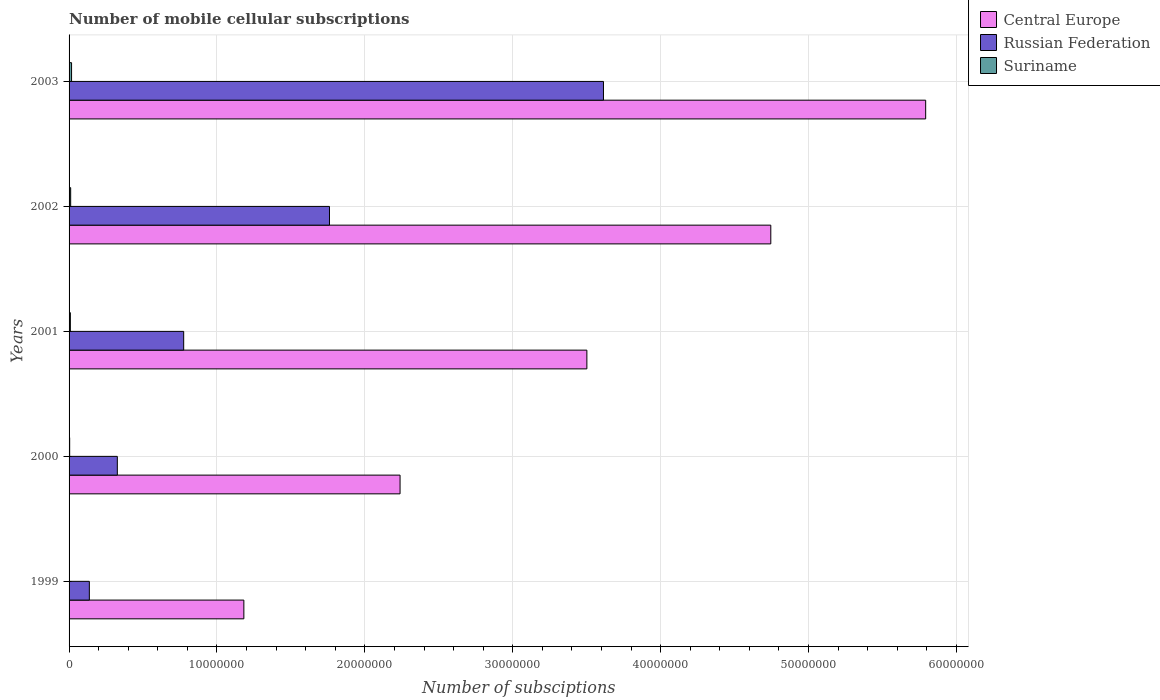How many groups of bars are there?
Your answer should be compact. 5. Are the number of bars per tick equal to the number of legend labels?
Provide a short and direct response. Yes. What is the label of the 4th group of bars from the top?
Provide a short and direct response. 2000. What is the number of mobile cellular subscriptions in Central Europe in 2002?
Provide a short and direct response. 4.74e+07. Across all years, what is the maximum number of mobile cellular subscriptions in Russian Federation?
Your answer should be very brief. 3.61e+07. Across all years, what is the minimum number of mobile cellular subscriptions in Russian Federation?
Make the answer very short. 1.37e+06. In which year was the number of mobile cellular subscriptions in Suriname maximum?
Ensure brevity in your answer.  2003. What is the total number of mobile cellular subscriptions in Russian Federation in the graph?
Provide a succinct answer. 6.61e+07. What is the difference between the number of mobile cellular subscriptions in Suriname in 2000 and that in 2001?
Give a very brief answer. -4.60e+04. What is the difference between the number of mobile cellular subscriptions in Suriname in 1999 and the number of mobile cellular subscriptions in Russian Federation in 2002?
Provide a succinct answer. -1.76e+07. What is the average number of mobile cellular subscriptions in Central Europe per year?
Offer a terse response. 3.49e+07. In the year 2001, what is the difference between the number of mobile cellular subscriptions in Suriname and number of mobile cellular subscriptions in Central Europe?
Provide a succinct answer. -3.49e+07. In how many years, is the number of mobile cellular subscriptions in Central Europe greater than 50000000 ?
Keep it short and to the point. 1. What is the ratio of the number of mobile cellular subscriptions in Suriname in 2000 to that in 2001?
Offer a very short reply. 0.47. Is the difference between the number of mobile cellular subscriptions in Suriname in 2001 and 2002 greater than the difference between the number of mobile cellular subscriptions in Central Europe in 2001 and 2002?
Your response must be concise. Yes. What is the difference between the highest and the second highest number of mobile cellular subscriptions in Suriname?
Provide a short and direct response. 6.02e+04. What is the difference between the highest and the lowest number of mobile cellular subscriptions in Central Europe?
Offer a very short reply. 4.61e+07. In how many years, is the number of mobile cellular subscriptions in Russian Federation greater than the average number of mobile cellular subscriptions in Russian Federation taken over all years?
Provide a succinct answer. 2. What does the 1st bar from the top in 1999 represents?
Give a very brief answer. Suriname. What does the 1st bar from the bottom in 2000 represents?
Offer a terse response. Central Europe. Is it the case that in every year, the sum of the number of mobile cellular subscriptions in Suriname and number of mobile cellular subscriptions in Central Europe is greater than the number of mobile cellular subscriptions in Russian Federation?
Make the answer very short. Yes. How many bars are there?
Provide a succinct answer. 15. What is the difference between two consecutive major ticks on the X-axis?
Provide a short and direct response. 1.00e+07. Does the graph contain grids?
Give a very brief answer. Yes. Where does the legend appear in the graph?
Offer a very short reply. Top right. How many legend labels are there?
Give a very brief answer. 3. How are the legend labels stacked?
Provide a short and direct response. Vertical. What is the title of the graph?
Offer a terse response. Number of mobile cellular subscriptions. Does "Papua New Guinea" appear as one of the legend labels in the graph?
Provide a succinct answer. No. What is the label or title of the X-axis?
Ensure brevity in your answer.  Number of subsciptions. What is the Number of subsciptions in Central Europe in 1999?
Keep it short and to the point. 1.18e+07. What is the Number of subsciptions in Russian Federation in 1999?
Provide a short and direct response. 1.37e+06. What is the Number of subsciptions of Suriname in 1999?
Provide a succinct answer. 1.75e+04. What is the Number of subsciptions in Central Europe in 2000?
Offer a very short reply. 2.24e+07. What is the Number of subsciptions of Russian Federation in 2000?
Your answer should be very brief. 3.26e+06. What is the Number of subsciptions in Suriname in 2000?
Provide a short and direct response. 4.10e+04. What is the Number of subsciptions in Central Europe in 2001?
Provide a short and direct response. 3.50e+07. What is the Number of subsciptions of Russian Federation in 2001?
Provide a succinct answer. 7.75e+06. What is the Number of subsciptions of Suriname in 2001?
Offer a terse response. 8.70e+04. What is the Number of subsciptions in Central Europe in 2002?
Offer a terse response. 4.74e+07. What is the Number of subsciptions in Russian Federation in 2002?
Make the answer very short. 1.76e+07. What is the Number of subsciptions in Suriname in 2002?
Give a very brief answer. 1.08e+05. What is the Number of subsciptions of Central Europe in 2003?
Offer a very short reply. 5.79e+07. What is the Number of subsciptions of Russian Federation in 2003?
Make the answer very short. 3.61e+07. What is the Number of subsciptions in Suriname in 2003?
Provide a succinct answer. 1.69e+05. Across all years, what is the maximum Number of subsciptions in Central Europe?
Give a very brief answer. 5.79e+07. Across all years, what is the maximum Number of subsciptions in Russian Federation?
Your response must be concise. 3.61e+07. Across all years, what is the maximum Number of subsciptions in Suriname?
Offer a terse response. 1.69e+05. Across all years, what is the minimum Number of subsciptions of Central Europe?
Give a very brief answer. 1.18e+07. Across all years, what is the minimum Number of subsciptions in Russian Federation?
Ensure brevity in your answer.  1.37e+06. Across all years, what is the minimum Number of subsciptions of Suriname?
Provide a short and direct response. 1.75e+04. What is the total Number of subsciptions of Central Europe in the graph?
Keep it short and to the point. 1.75e+08. What is the total Number of subsciptions of Russian Federation in the graph?
Your response must be concise. 6.61e+07. What is the total Number of subsciptions of Suriname in the graph?
Make the answer very short. 4.22e+05. What is the difference between the Number of subsciptions in Central Europe in 1999 and that in 2000?
Offer a very short reply. -1.06e+07. What is the difference between the Number of subsciptions in Russian Federation in 1999 and that in 2000?
Provide a succinct answer. -1.89e+06. What is the difference between the Number of subsciptions in Suriname in 1999 and that in 2000?
Make the answer very short. -2.35e+04. What is the difference between the Number of subsciptions in Central Europe in 1999 and that in 2001?
Your response must be concise. -2.32e+07. What is the difference between the Number of subsciptions of Russian Federation in 1999 and that in 2001?
Provide a short and direct response. -6.38e+06. What is the difference between the Number of subsciptions of Suriname in 1999 and that in 2001?
Your response must be concise. -6.95e+04. What is the difference between the Number of subsciptions in Central Europe in 1999 and that in 2002?
Keep it short and to the point. -3.56e+07. What is the difference between the Number of subsciptions in Russian Federation in 1999 and that in 2002?
Keep it short and to the point. -1.62e+07. What is the difference between the Number of subsciptions of Suriname in 1999 and that in 2002?
Ensure brevity in your answer.  -9.09e+04. What is the difference between the Number of subsciptions in Central Europe in 1999 and that in 2003?
Offer a terse response. -4.61e+07. What is the difference between the Number of subsciptions of Russian Federation in 1999 and that in 2003?
Give a very brief answer. -3.48e+07. What is the difference between the Number of subsciptions in Suriname in 1999 and that in 2003?
Offer a terse response. -1.51e+05. What is the difference between the Number of subsciptions in Central Europe in 2000 and that in 2001?
Offer a very short reply. -1.26e+07. What is the difference between the Number of subsciptions in Russian Federation in 2000 and that in 2001?
Make the answer very short. -4.49e+06. What is the difference between the Number of subsciptions in Suriname in 2000 and that in 2001?
Give a very brief answer. -4.60e+04. What is the difference between the Number of subsciptions in Central Europe in 2000 and that in 2002?
Give a very brief answer. -2.51e+07. What is the difference between the Number of subsciptions in Russian Federation in 2000 and that in 2002?
Give a very brief answer. -1.43e+07. What is the difference between the Number of subsciptions of Suriname in 2000 and that in 2002?
Offer a terse response. -6.73e+04. What is the difference between the Number of subsciptions of Central Europe in 2000 and that in 2003?
Your response must be concise. -3.55e+07. What is the difference between the Number of subsciptions of Russian Federation in 2000 and that in 2003?
Your answer should be very brief. -3.29e+07. What is the difference between the Number of subsciptions of Suriname in 2000 and that in 2003?
Offer a very short reply. -1.27e+05. What is the difference between the Number of subsciptions of Central Europe in 2001 and that in 2002?
Offer a terse response. -1.24e+07. What is the difference between the Number of subsciptions of Russian Federation in 2001 and that in 2002?
Your response must be concise. -9.86e+06. What is the difference between the Number of subsciptions in Suriname in 2001 and that in 2002?
Give a very brief answer. -2.14e+04. What is the difference between the Number of subsciptions of Central Europe in 2001 and that in 2003?
Ensure brevity in your answer.  -2.29e+07. What is the difference between the Number of subsciptions of Russian Federation in 2001 and that in 2003?
Your answer should be compact. -2.84e+07. What is the difference between the Number of subsciptions of Suriname in 2001 and that in 2003?
Your answer should be very brief. -8.15e+04. What is the difference between the Number of subsciptions of Central Europe in 2002 and that in 2003?
Keep it short and to the point. -1.05e+07. What is the difference between the Number of subsciptions of Russian Federation in 2002 and that in 2003?
Your answer should be compact. -1.85e+07. What is the difference between the Number of subsciptions in Suriname in 2002 and that in 2003?
Keep it short and to the point. -6.02e+04. What is the difference between the Number of subsciptions in Central Europe in 1999 and the Number of subsciptions in Russian Federation in 2000?
Keep it short and to the point. 8.56e+06. What is the difference between the Number of subsciptions in Central Europe in 1999 and the Number of subsciptions in Suriname in 2000?
Offer a very short reply. 1.18e+07. What is the difference between the Number of subsciptions of Russian Federation in 1999 and the Number of subsciptions of Suriname in 2000?
Give a very brief answer. 1.33e+06. What is the difference between the Number of subsciptions in Central Europe in 1999 and the Number of subsciptions in Russian Federation in 2001?
Keep it short and to the point. 4.07e+06. What is the difference between the Number of subsciptions of Central Europe in 1999 and the Number of subsciptions of Suriname in 2001?
Your answer should be very brief. 1.17e+07. What is the difference between the Number of subsciptions of Russian Federation in 1999 and the Number of subsciptions of Suriname in 2001?
Provide a succinct answer. 1.28e+06. What is the difference between the Number of subsciptions of Central Europe in 1999 and the Number of subsciptions of Russian Federation in 2002?
Offer a very short reply. -5.79e+06. What is the difference between the Number of subsciptions in Central Europe in 1999 and the Number of subsciptions in Suriname in 2002?
Ensure brevity in your answer.  1.17e+07. What is the difference between the Number of subsciptions in Russian Federation in 1999 and the Number of subsciptions in Suriname in 2002?
Ensure brevity in your answer.  1.26e+06. What is the difference between the Number of subsciptions of Central Europe in 1999 and the Number of subsciptions of Russian Federation in 2003?
Ensure brevity in your answer.  -2.43e+07. What is the difference between the Number of subsciptions in Central Europe in 1999 and the Number of subsciptions in Suriname in 2003?
Offer a very short reply. 1.17e+07. What is the difference between the Number of subsciptions in Russian Federation in 1999 and the Number of subsciptions in Suriname in 2003?
Your answer should be very brief. 1.20e+06. What is the difference between the Number of subsciptions of Central Europe in 2000 and the Number of subsciptions of Russian Federation in 2001?
Offer a terse response. 1.46e+07. What is the difference between the Number of subsciptions in Central Europe in 2000 and the Number of subsciptions in Suriname in 2001?
Your response must be concise. 2.23e+07. What is the difference between the Number of subsciptions of Russian Federation in 2000 and the Number of subsciptions of Suriname in 2001?
Your answer should be very brief. 3.18e+06. What is the difference between the Number of subsciptions in Central Europe in 2000 and the Number of subsciptions in Russian Federation in 2002?
Provide a short and direct response. 4.77e+06. What is the difference between the Number of subsciptions in Central Europe in 2000 and the Number of subsciptions in Suriname in 2002?
Your response must be concise. 2.23e+07. What is the difference between the Number of subsciptions of Russian Federation in 2000 and the Number of subsciptions of Suriname in 2002?
Your answer should be compact. 3.15e+06. What is the difference between the Number of subsciptions of Central Europe in 2000 and the Number of subsciptions of Russian Federation in 2003?
Your answer should be very brief. -1.38e+07. What is the difference between the Number of subsciptions in Central Europe in 2000 and the Number of subsciptions in Suriname in 2003?
Offer a very short reply. 2.22e+07. What is the difference between the Number of subsciptions in Russian Federation in 2000 and the Number of subsciptions in Suriname in 2003?
Your answer should be very brief. 3.09e+06. What is the difference between the Number of subsciptions of Central Europe in 2001 and the Number of subsciptions of Russian Federation in 2002?
Provide a short and direct response. 1.74e+07. What is the difference between the Number of subsciptions of Central Europe in 2001 and the Number of subsciptions of Suriname in 2002?
Provide a succinct answer. 3.49e+07. What is the difference between the Number of subsciptions in Russian Federation in 2001 and the Number of subsciptions in Suriname in 2002?
Ensure brevity in your answer.  7.64e+06. What is the difference between the Number of subsciptions of Central Europe in 2001 and the Number of subsciptions of Russian Federation in 2003?
Provide a succinct answer. -1.12e+06. What is the difference between the Number of subsciptions of Central Europe in 2001 and the Number of subsciptions of Suriname in 2003?
Make the answer very short. 3.48e+07. What is the difference between the Number of subsciptions in Russian Federation in 2001 and the Number of subsciptions in Suriname in 2003?
Offer a very short reply. 7.58e+06. What is the difference between the Number of subsciptions in Central Europe in 2002 and the Number of subsciptions in Russian Federation in 2003?
Make the answer very short. 1.13e+07. What is the difference between the Number of subsciptions in Central Europe in 2002 and the Number of subsciptions in Suriname in 2003?
Give a very brief answer. 4.73e+07. What is the difference between the Number of subsciptions in Russian Federation in 2002 and the Number of subsciptions in Suriname in 2003?
Your response must be concise. 1.74e+07. What is the average Number of subsciptions in Central Europe per year?
Your answer should be compact. 3.49e+07. What is the average Number of subsciptions in Russian Federation per year?
Offer a very short reply. 1.32e+07. What is the average Number of subsciptions of Suriname per year?
Offer a very short reply. 8.45e+04. In the year 1999, what is the difference between the Number of subsciptions in Central Europe and Number of subsciptions in Russian Federation?
Your response must be concise. 1.04e+07. In the year 1999, what is the difference between the Number of subsciptions of Central Europe and Number of subsciptions of Suriname?
Offer a terse response. 1.18e+07. In the year 1999, what is the difference between the Number of subsciptions of Russian Federation and Number of subsciptions of Suriname?
Provide a short and direct response. 1.35e+06. In the year 2000, what is the difference between the Number of subsciptions of Central Europe and Number of subsciptions of Russian Federation?
Give a very brief answer. 1.91e+07. In the year 2000, what is the difference between the Number of subsciptions in Central Europe and Number of subsciptions in Suriname?
Offer a very short reply. 2.23e+07. In the year 2000, what is the difference between the Number of subsciptions of Russian Federation and Number of subsciptions of Suriname?
Keep it short and to the point. 3.22e+06. In the year 2001, what is the difference between the Number of subsciptions of Central Europe and Number of subsciptions of Russian Federation?
Provide a succinct answer. 2.73e+07. In the year 2001, what is the difference between the Number of subsciptions in Central Europe and Number of subsciptions in Suriname?
Offer a terse response. 3.49e+07. In the year 2001, what is the difference between the Number of subsciptions in Russian Federation and Number of subsciptions in Suriname?
Your answer should be very brief. 7.66e+06. In the year 2002, what is the difference between the Number of subsciptions of Central Europe and Number of subsciptions of Russian Federation?
Your response must be concise. 2.98e+07. In the year 2002, what is the difference between the Number of subsciptions of Central Europe and Number of subsciptions of Suriname?
Ensure brevity in your answer.  4.73e+07. In the year 2002, what is the difference between the Number of subsciptions of Russian Federation and Number of subsciptions of Suriname?
Provide a succinct answer. 1.75e+07. In the year 2003, what is the difference between the Number of subsciptions of Central Europe and Number of subsciptions of Russian Federation?
Offer a terse response. 2.18e+07. In the year 2003, what is the difference between the Number of subsciptions of Central Europe and Number of subsciptions of Suriname?
Offer a terse response. 5.78e+07. In the year 2003, what is the difference between the Number of subsciptions in Russian Federation and Number of subsciptions in Suriname?
Give a very brief answer. 3.60e+07. What is the ratio of the Number of subsciptions in Central Europe in 1999 to that in 2000?
Ensure brevity in your answer.  0.53. What is the ratio of the Number of subsciptions in Russian Federation in 1999 to that in 2000?
Make the answer very short. 0.42. What is the ratio of the Number of subsciptions of Suriname in 1999 to that in 2000?
Your answer should be compact. 0.43. What is the ratio of the Number of subsciptions of Central Europe in 1999 to that in 2001?
Your answer should be very brief. 0.34. What is the ratio of the Number of subsciptions of Russian Federation in 1999 to that in 2001?
Keep it short and to the point. 0.18. What is the ratio of the Number of subsciptions of Suriname in 1999 to that in 2001?
Give a very brief answer. 0.2. What is the ratio of the Number of subsciptions of Central Europe in 1999 to that in 2002?
Provide a succinct answer. 0.25. What is the ratio of the Number of subsciptions of Russian Federation in 1999 to that in 2002?
Keep it short and to the point. 0.08. What is the ratio of the Number of subsciptions in Suriname in 1999 to that in 2002?
Provide a short and direct response. 0.16. What is the ratio of the Number of subsciptions of Central Europe in 1999 to that in 2003?
Your answer should be very brief. 0.2. What is the ratio of the Number of subsciptions of Russian Federation in 1999 to that in 2003?
Keep it short and to the point. 0.04. What is the ratio of the Number of subsciptions in Suriname in 1999 to that in 2003?
Ensure brevity in your answer.  0.1. What is the ratio of the Number of subsciptions in Central Europe in 2000 to that in 2001?
Make the answer very short. 0.64. What is the ratio of the Number of subsciptions in Russian Federation in 2000 to that in 2001?
Your response must be concise. 0.42. What is the ratio of the Number of subsciptions in Suriname in 2000 to that in 2001?
Provide a succinct answer. 0.47. What is the ratio of the Number of subsciptions of Central Europe in 2000 to that in 2002?
Keep it short and to the point. 0.47. What is the ratio of the Number of subsciptions in Russian Federation in 2000 to that in 2002?
Make the answer very short. 0.19. What is the ratio of the Number of subsciptions in Suriname in 2000 to that in 2002?
Offer a terse response. 0.38. What is the ratio of the Number of subsciptions in Central Europe in 2000 to that in 2003?
Provide a succinct answer. 0.39. What is the ratio of the Number of subsciptions in Russian Federation in 2000 to that in 2003?
Offer a very short reply. 0.09. What is the ratio of the Number of subsciptions in Suriname in 2000 to that in 2003?
Provide a succinct answer. 0.24. What is the ratio of the Number of subsciptions in Central Europe in 2001 to that in 2002?
Offer a very short reply. 0.74. What is the ratio of the Number of subsciptions in Russian Federation in 2001 to that in 2002?
Make the answer very short. 0.44. What is the ratio of the Number of subsciptions of Suriname in 2001 to that in 2002?
Give a very brief answer. 0.8. What is the ratio of the Number of subsciptions in Central Europe in 2001 to that in 2003?
Provide a succinct answer. 0.6. What is the ratio of the Number of subsciptions in Russian Federation in 2001 to that in 2003?
Your answer should be very brief. 0.21. What is the ratio of the Number of subsciptions in Suriname in 2001 to that in 2003?
Your response must be concise. 0.52. What is the ratio of the Number of subsciptions in Central Europe in 2002 to that in 2003?
Provide a short and direct response. 0.82. What is the ratio of the Number of subsciptions of Russian Federation in 2002 to that in 2003?
Give a very brief answer. 0.49. What is the ratio of the Number of subsciptions in Suriname in 2002 to that in 2003?
Provide a succinct answer. 0.64. What is the difference between the highest and the second highest Number of subsciptions in Central Europe?
Your response must be concise. 1.05e+07. What is the difference between the highest and the second highest Number of subsciptions of Russian Federation?
Ensure brevity in your answer.  1.85e+07. What is the difference between the highest and the second highest Number of subsciptions of Suriname?
Give a very brief answer. 6.02e+04. What is the difference between the highest and the lowest Number of subsciptions of Central Europe?
Ensure brevity in your answer.  4.61e+07. What is the difference between the highest and the lowest Number of subsciptions in Russian Federation?
Make the answer very short. 3.48e+07. What is the difference between the highest and the lowest Number of subsciptions of Suriname?
Your answer should be compact. 1.51e+05. 